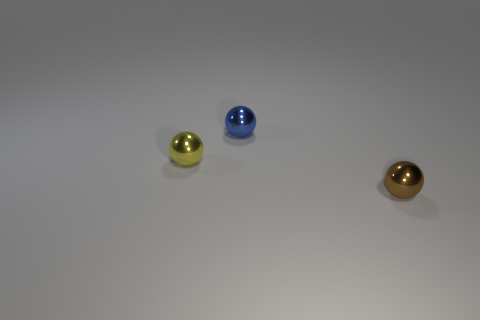Add 3 metallic objects. How many objects exist? 6 Subtract all brown balls. How many balls are left? 2 Subtract all yellow balls. How many balls are left? 2 Subtract 3 balls. How many balls are left? 0 Add 3 green metallic blocks. How many green metallic blocks exist? 3 Subtract 0 gray cylinders. How many objects are left? 3 Subtract all cyan spheres. Subtract all cyan cubes. How many spheres are left? 3 Subtract all yellow cylinders. How many brown spheres are left? 1 Subtract all small objects. Subtract all gray metallic cylinders. How many objects are left? 0 Add 2 blue shiny balls. How many blue shiny balls are left? 3 